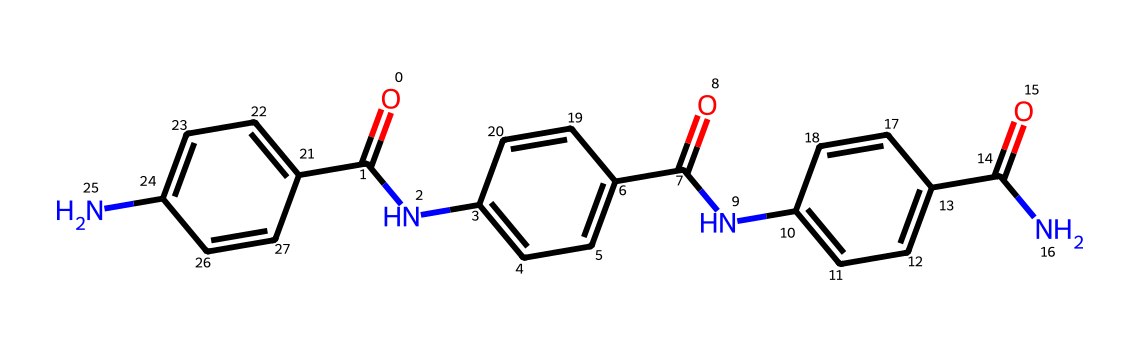How many carbon atoms are in this chemical? To find the number of carbon atoms, we can count the 'C' symbols in the SMILES representation. Each 'C' represents one carbon atom. By scanning the SMILES, we see multiple occurrences of 'C', leading us to count a total of 15 carbon atoms.
Answer: 15 What type of chemical structure is this? The SMILES indicates a compound with multiple amide functionalities due to the presence of the 'N' atoms and the carbonyl groups 'C(=O)'. This suggests that it belongs to the category of fibers or polymers, specifically those used for heat resistance, typical in firefighter gloves.
Answer: amide How many nitrogen atoms are in this chemical? Similar to counting the carbon atoms, we look for 'N' in the SMILES representation. Each 'N' indicates one nitrogen atom. By inspecting the SMILES, we find 4 nitrogen atoms in total.
Answer: 4 Does this chemical have aromatic rings? Yes, we can see several 'c' symbols in the SMILES, which indicates the presence of aromatic rings. Specifically, the patterns and structures around those 'c' symbols reinforce that there are aromatic systems within the chemical.
Answer: yes Which functional groups are present in this chemical? By analyzing the SMILES, we identify the presence of carbonyl groups (noted by 'C(=O)') and amine groups (indicated by 'N'). These confirm the presence of both amide functional groups in the structure.
Answer: amide and carbonyl groups What aspect of this chemical contributes to its heat resistance? The presence of strong covalent bonds due to the aromatic rings and the amide linkages in this chemical structure contributes to its thermal stability and heat-resistant properties, which are essential for materials used in firefighting gloves.
Answer: aromatic rings and amides Is this chemical soluble in water? Given the presence of hydrophobic aromatic rings and amidic structures that don't favor solubility, it is likely this chemical is not very soluble in water.
Answer: no 